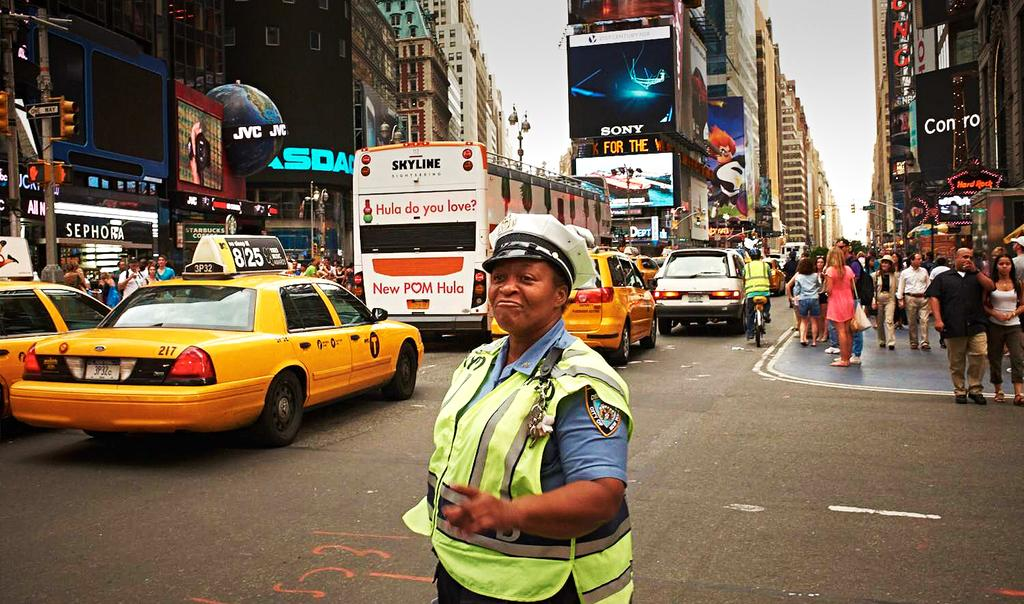Provide a one-sentence caption for the provided image. A woman directs traffic on a busy street filled with cars and pedestrians, in front of an advertismeent for Sony and Conro. 